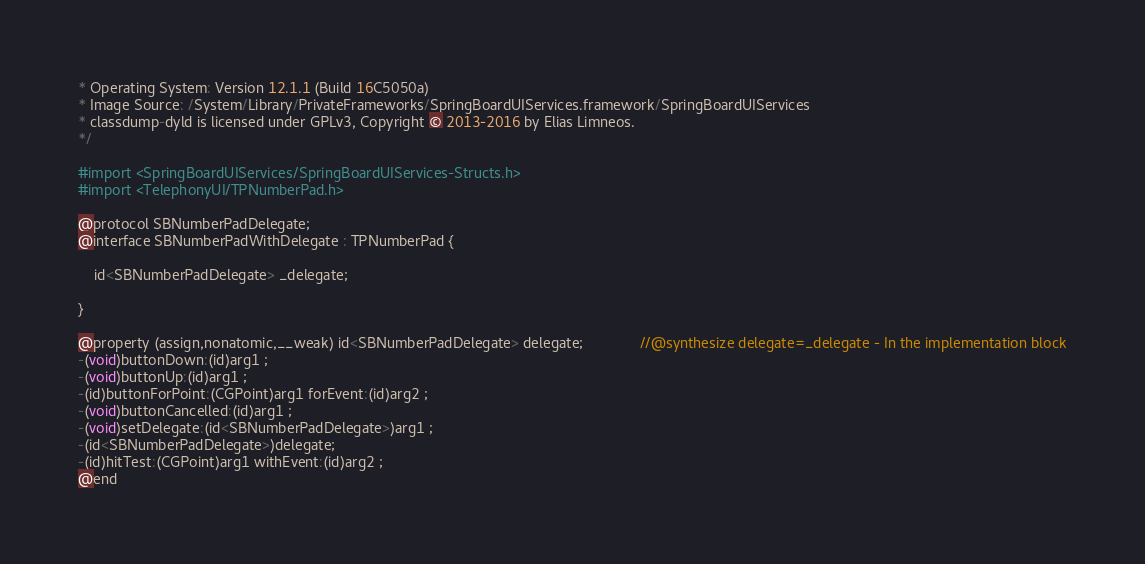Convert code to text. <code><loc_0><loc_0><loc_500><loc_500><_C_>* Operating System: Version 12.1.1 (Build 16C5050a)
* Image Source: /System/Library/PrivateFrameworks/SpringBoardUIServices.framework/SpringBoardUIServices
* classdump-dyld is licensed under GPLv3, Copyright © 2013-2016 by Elias Limneos.
*/

#import <SpringBoardUIServices/SpringBoardUIServices-Structs.h>
#import <TelephonyUI/TPNumberPad.h>

@protocol SBNumberPadDelegate;
@interface SBNumberPadWithDelegate : TPNumberPad {

	id<SBNumberPadDelegate> _delegate;

}

@property (assign,nonatomic,__weak) id<SBNumberPadDelegate> delegate;              //@synthesize delegate=_delegate - In the implementation block
-(void)buttonDown:(id)arg1 ;
-(void)buttonUp:(id)arg1 ;
-(id)buttonForPoint:(CGPoint)arg1 forEvent:(id)arg2 ;
-(void)buttonCancelled:(id)arg1 ;
-(void)setDelegate:(id<SBNumberPadDelegate>)arg1 ;
-(id<SBNumberPadDelegate>)delegate;
-(id)hitTest:(CGPoint)arg1 withEvent:(id)arg2 ;
@end

</code> 